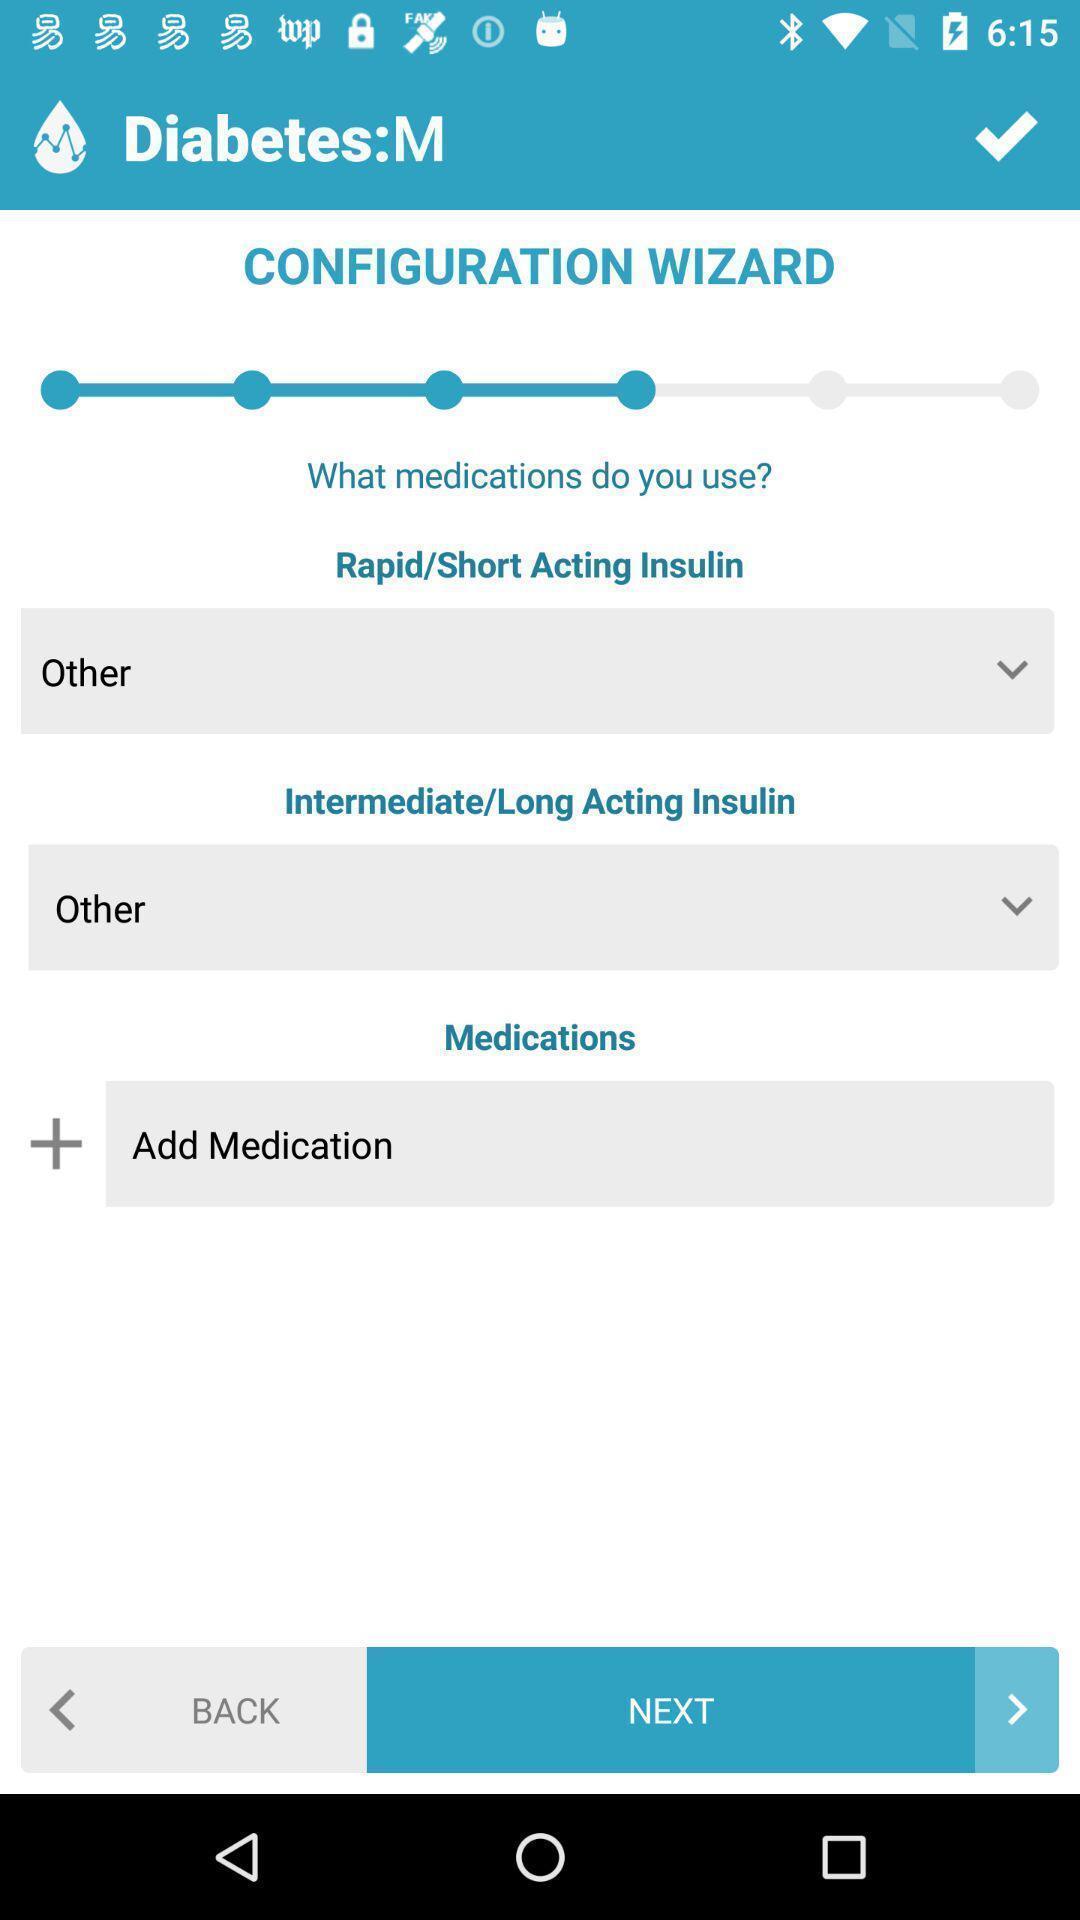Provide a textual representation of this image. Page showing different setting options on an app. 